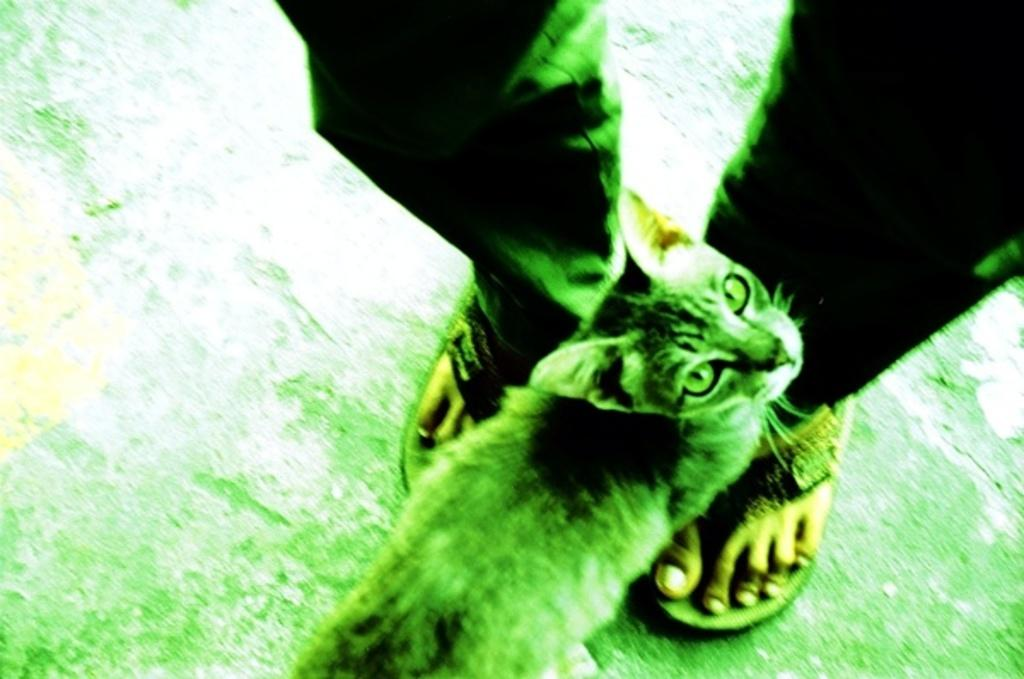What type of animal is in the image? There is a cat in the image. Where is the cat located in relation to a person? The cat is near a person's legs. What colors are predominant in the image? The image is predominantly white and green in color. What type of tin is the cat using to write a message in the image? There is no tin or writing activity present in the image; it features a cat near a person's legs. How many bells can be heard ringing in the image? There are no bells present in the image, so it is not possible to determine how many might be ringing. 